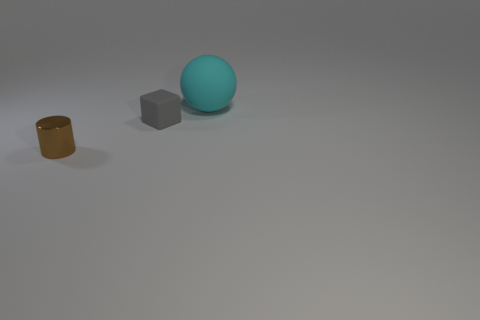Add 1 large purple rubber balls. How many objects exist? 4 Subtract all blocks. How many objects are left? 2 Add 2 large things. How many large things exist? 3 Subtract 0 green cylinders. How many objects are left? 3 Subtract all tiny metal objects. Subtract all large spheres. How many objects are left? 1 Add 2 blocks. How many blocks are left? 3 